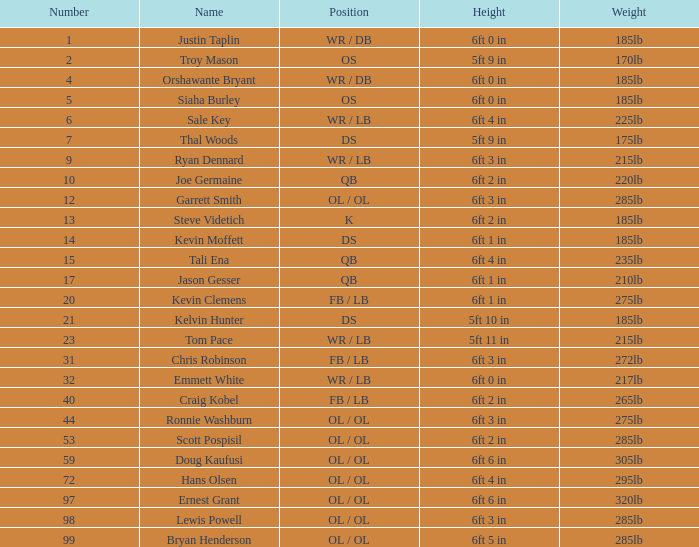What is the number for the player that has a k position? 13.0. 